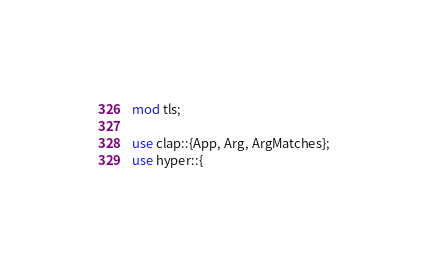Convert code to text. <code><loc_0><loc_0><loc_500><loc_500><_Rust_>mod tls;

use clap::{App, Arg, ArgMatches};
use hyper::{</code> 